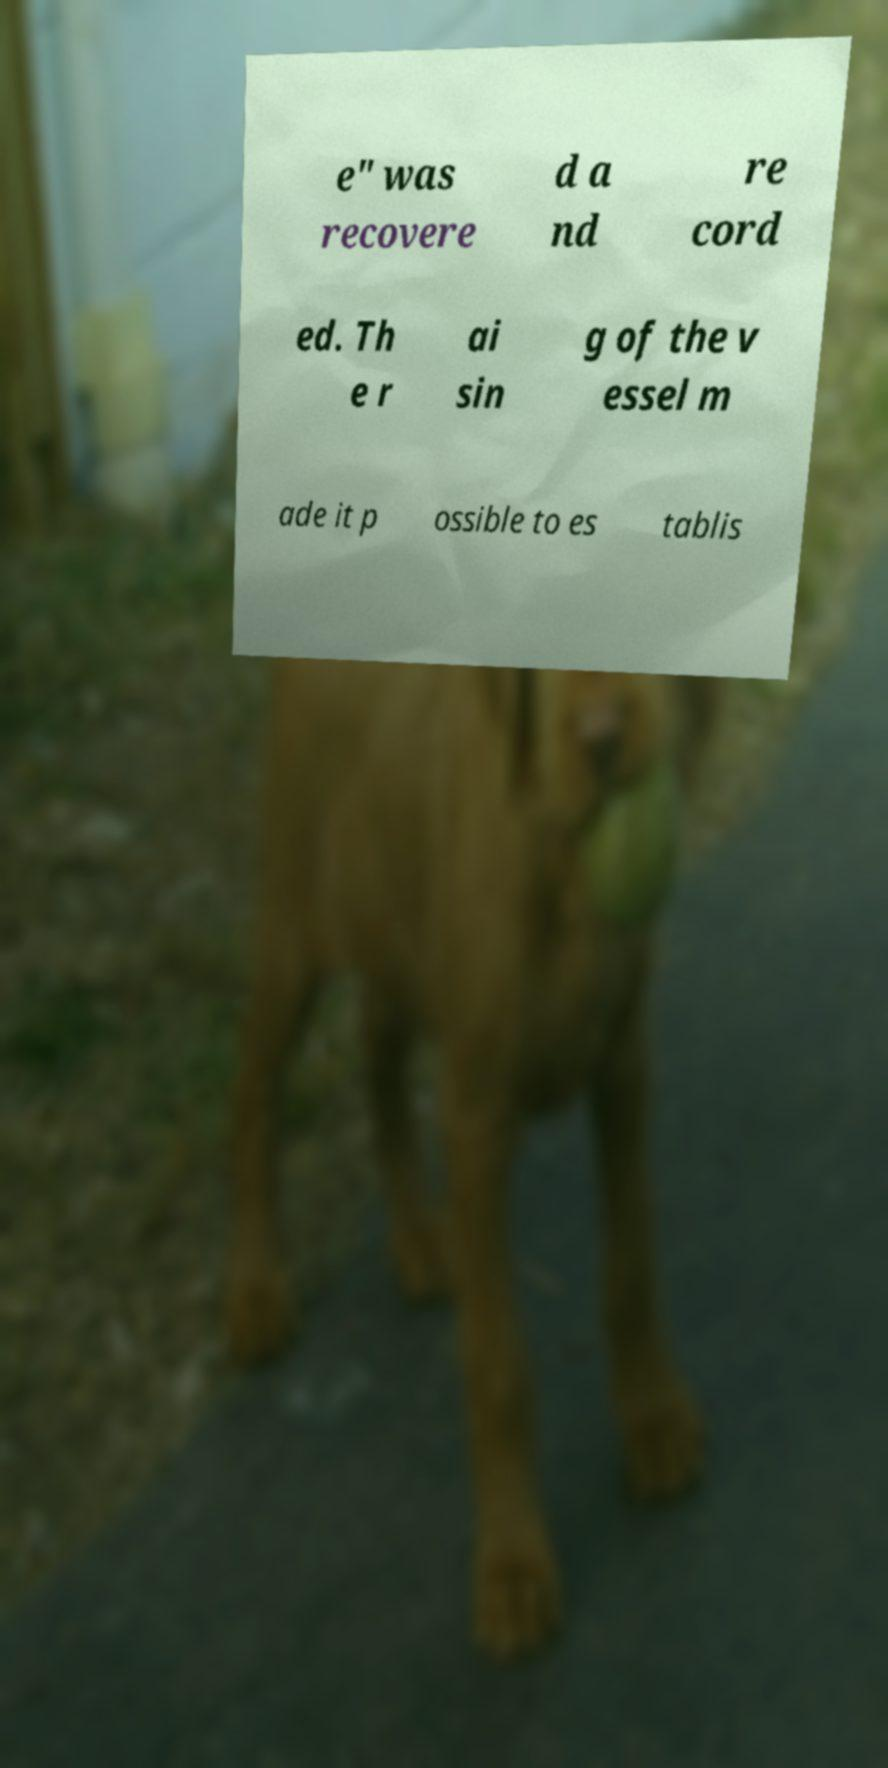What messages or text are displayed in this image? I need them in a readable, typed format. e" was recovere d a nd re cord ed. Th e r ai sin g of the v essel m ade it p ossible to es tablis 